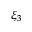Convert formula to latex. <formula><loc_0><loc_0><loc_500><loc_500>\xi _ { 3 }</formula> 